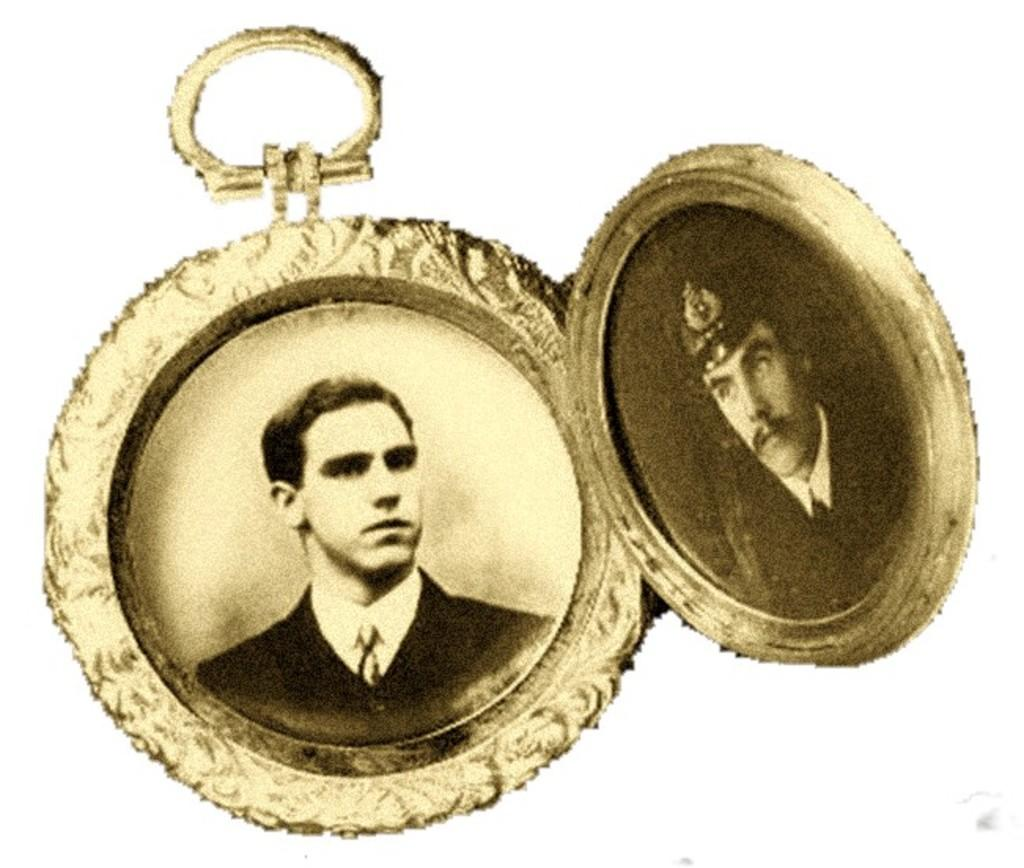What is the main object in the image? There is a pendant in the image. What is depicted on the pendant? The pendant contains two photos. What is the color of the pendant? The pendant is gold in color. How does the pendant help the person wearing it to breathe better? The pendant does not have any function related to breathing; it is simply a decorative object containing two photos. 